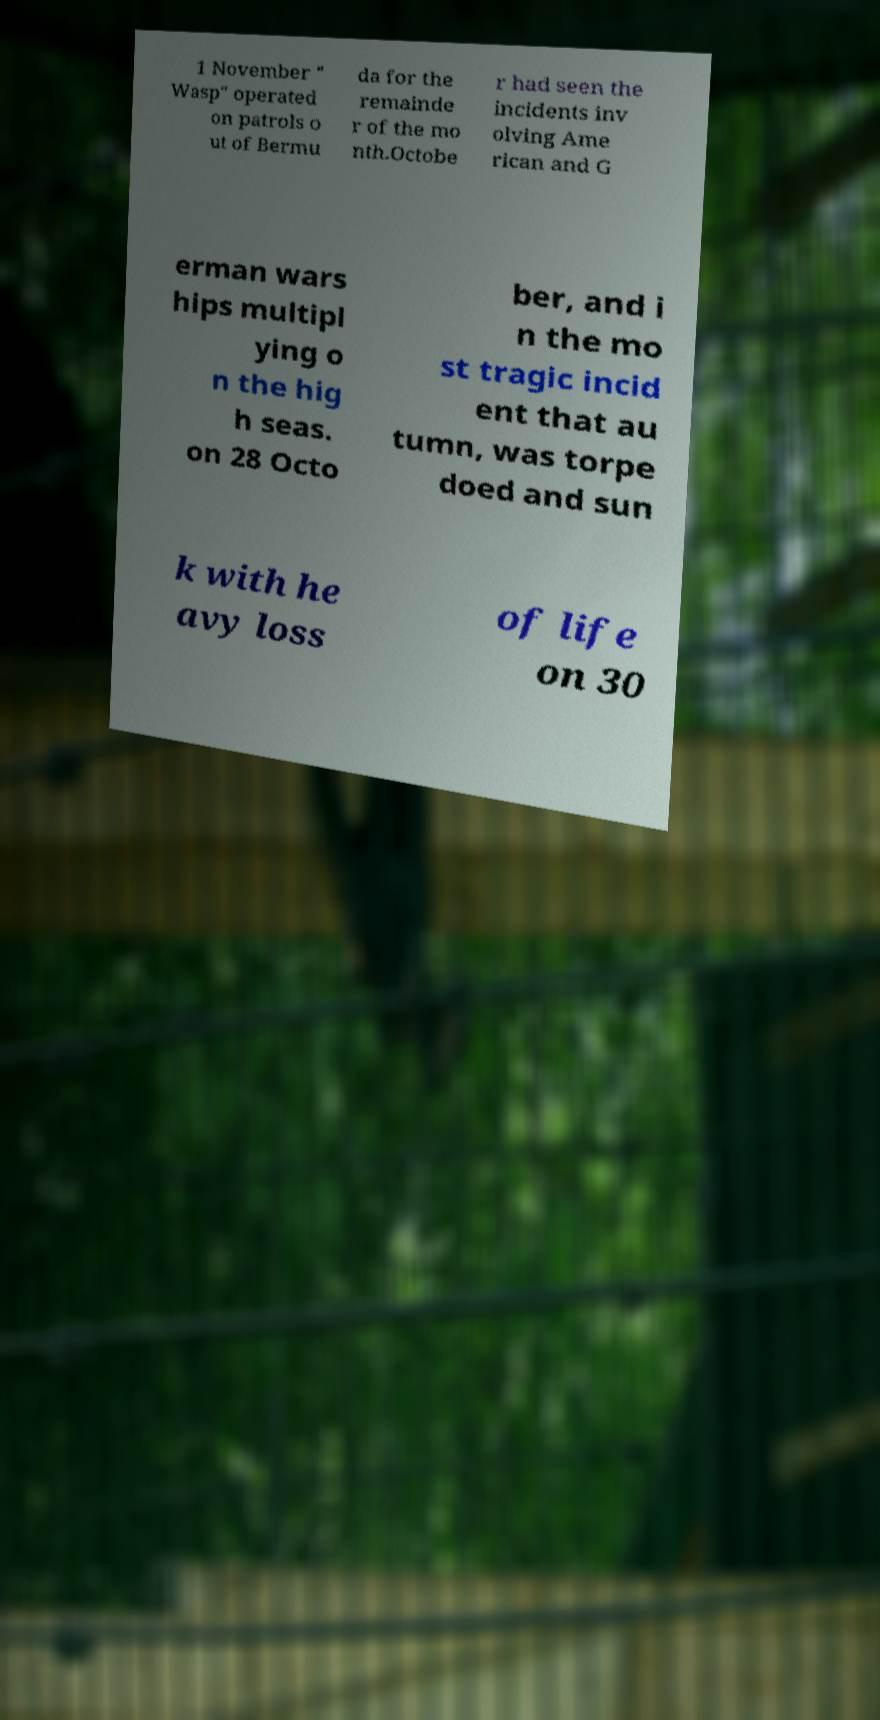Can you read and provide the text displayed in the image?This photo seems to have some interesting text. Can you extract and type it out for me? 1 November " Wasp" operated on patrols o ut of Bermu da for the remainde r of the mo nth.Octobe r had seen the incidents inv olving Ame rican and G erman wars hips multipl ying o n the hig h seas. on 28 Octo ber, and i n the mo st tragic incid ent that au tumn, was torpe doed and sun k with he avy loss of life on 30 